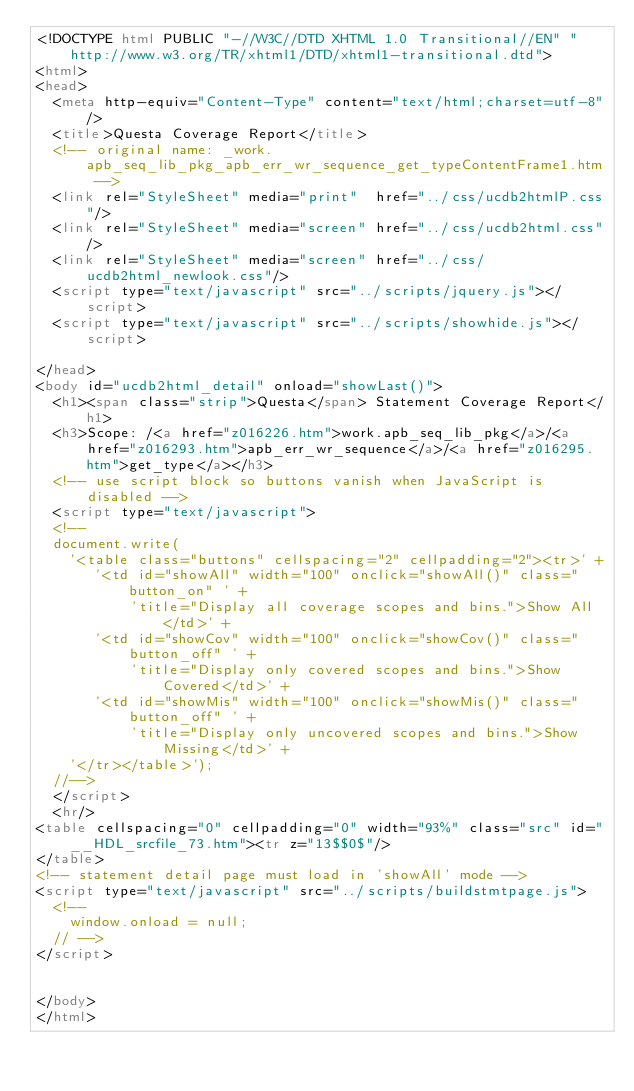Convert code to text. <code><loc_0><loc_0><loc_500><loc_500><_HTML_><!DOCTYPE html PUBLIC "-//W3C//DTD XHTML 1.0 Transitional//EN" "http://www.w3.org/TR/xhtml1/DTD/xhtml1-transitional.dtd">
<html>
<head>
  <meta http-equiv="Content-Type" content="text/html;charset=utf-8"/>
  <title>Questa Coverage Report</title>
  <!-- original name: _work.apb_seq_lib_pkg_apb_err_wr_sequence_get_typeContentFrame1.htm -->
  <link rel="StyleSheet" media="print"  href="../css/ucdb2htmlP.css"/>
  <link rel="StyleSheet" media="screen" href="../css/ucdb2html.css"/>
  <link rel="StyleSheet" media="screen" href="../css/ucdb2html_newlook.css"/>
  <script type="text/javascript" src="../scripts/jquery.js"></script>
  <script type="text/javascript" src="../scripts/showhide.js"></script>
  
</head>
<body id="ucdb2html_detail" onload="showLast()">
  <h1><span class="strip">Questa</span> Statement Coverage Report</h1>
  <h3>Scope: /<a href="z016226.htm">work.apb_seq_lib_pkg</a>/<a href="z016293.htm">apb_err_wr_sequence</a>/<a href="z016295.htm">get_type</a></h3>
  <!-- use script block so buttons vanish when JavaScript is disabled -->
  <script type="text/javascript">
  <!--
  document.write(
    '<table class="buttons" cellspacing="2" cellpadding="2"><tr>' +
       '<td id="showAll" width="100" onclick="showAll()" class="button_on" ' +
           'title="Display all coverage scopes and bins.">Show All</td>' +
       '<td id="showCov" width="100" onclick="showCov()" class="button_off" ' +
           'title="Display only covered scopes and bins.">Show Covered</td>' +
       '<td id="showMis" width="100" onclick="showMis()" class="button_off" ' +
           'title="Display only uncovered scopes and bins.">Show Missing</td>' +
    '</tr></table>');
  //-->
  </script>
  <hr/>
<table cellspacing="0" cellpadding="0" width="93%" class="src" id="__HDL_srcfile_73.htm"><tr z="13$$0$"/>
</table>
<!-- statement detail page must load in 'showAll' mode -->
<script type="text/javascript" src="../scripts/buildstmtpage.js">
  <!--
    window.onload = null;
  // -->
</script>

  
</body>
</html>
</code> 